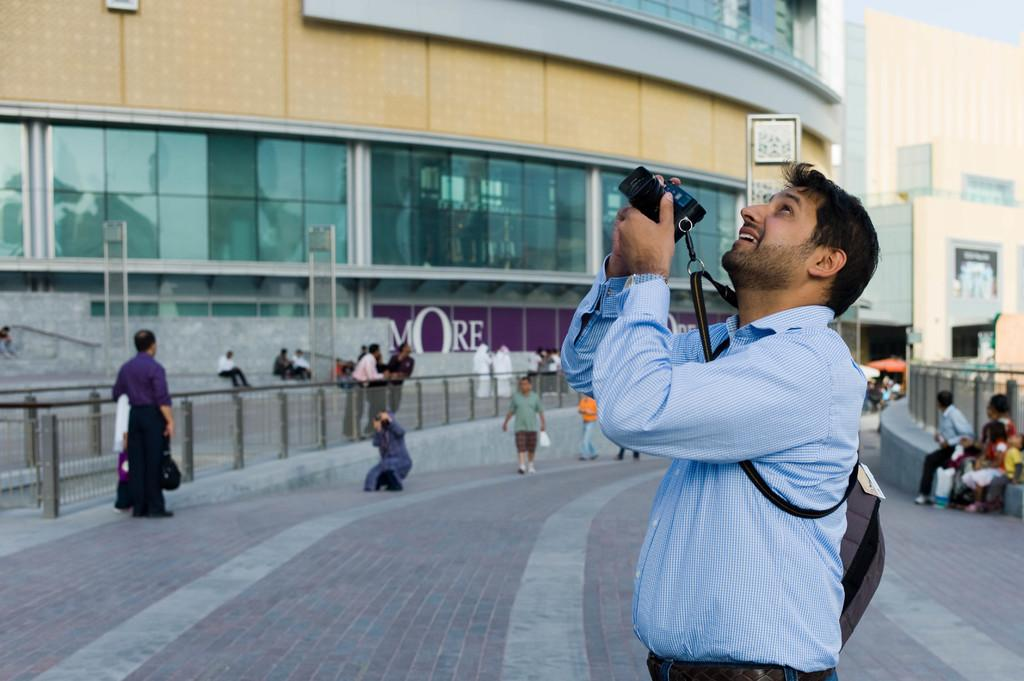Who or what can be seen in the image? There are people and buildings in the image. What are the name boards used for in the image? Name boards are present in the image, likely for identification purposes. What is the fence used for in the image? The fence is likely used for separation or security purposes in the image. What is visible at the bottom of the image? The floor, a person, a camera, and other objects are visible at the bottom of the image. What type of bun is being served to the laborer in the image? There is no bun or laborer present in the image. How does the society depicted in the image function? The image does not provide enough information to determine how the society functions. 